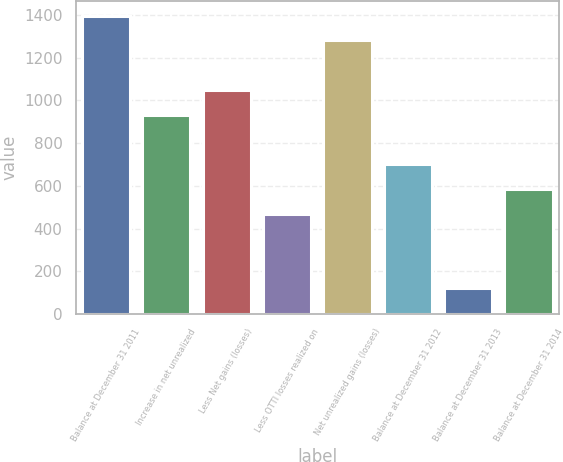Convert chart. <chart><loc_0><loc_0><loc_500><loc_500><bar_chart><fcel>Balance at December 31 2011<fcel>Increase in net unrealized<fcel>Less Net gains (losses)<fcel>Less OTTI losses realized on<fcel>Net unrealized gains (losses)<fcel>Balance at December 31 2012<fcel>Balance at December 31 2013<fcel>Balance at December 31 2014<nl><fcel>1398<fcel>934<fcel>1050<fcel>470<fcel>1282<fcel>702<fcel>122<fcel>586<nl></chart> 